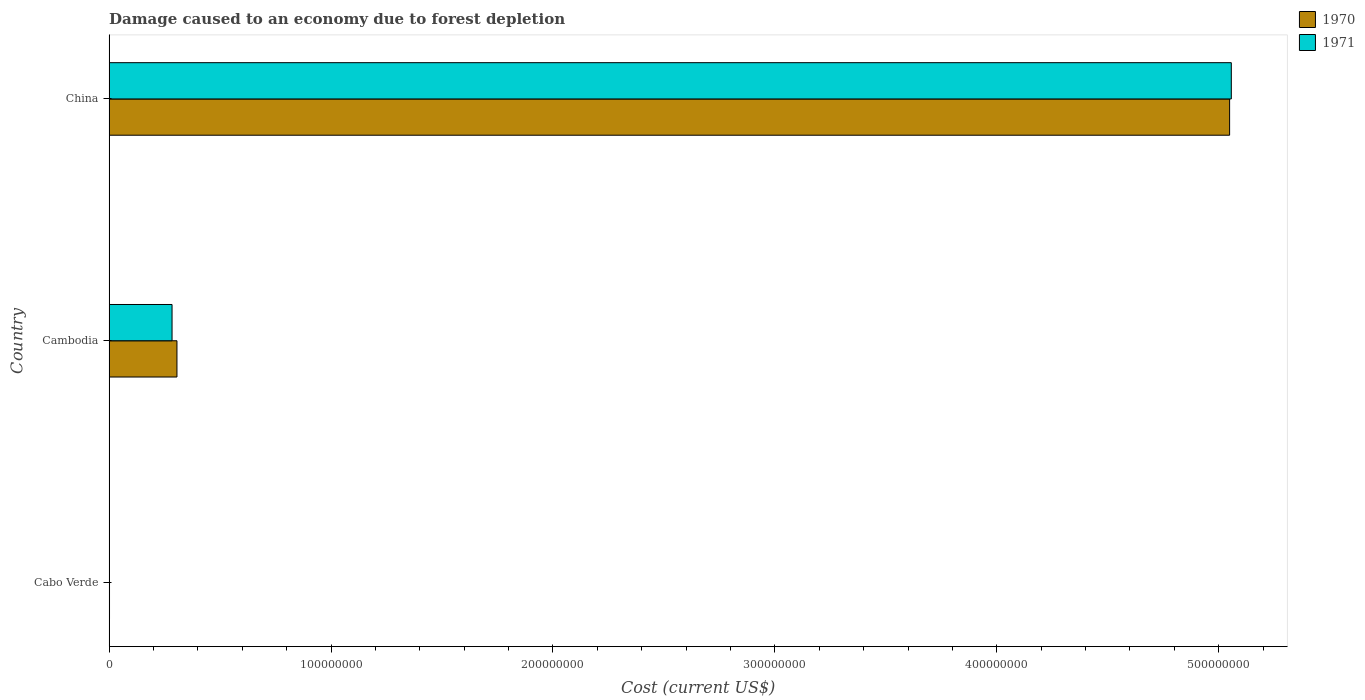Are the number of bars per tick equal to the number of legend labels?
Ensure brevity in your answer.  Yes. How many bars are there on the 2nd tick from the top?
Your answer should be compact. 2. What is the label of the 3rd group of bars from the top?
Ensure brevity in your answer.  Cabo Verde. In how many cases, is the number of bars for a given country not equal to the number of legend labels?
Make the answer very short. 0. What is the cost of damage caused due to forest depletion in 1970 in Cabo Verde?
Provide a succinct answer. 2.02e+05. Across all countries, what is the maximum cost of damage caused due to forest depletion in 1971?
Give a very brief answer. 5.06e+08. Across all countries, what is the minimum cost of damage caused due to forest depletion in 1971?
Make the answer very short. 1.81e+05. In which country was the cost of damage caused due to forest depletion in 1970 maximum?
Your answer should be compact. China. In which country was the cost of damage caused due to forest depletion in 1970 minimum?
Your answer should be compact. Cabo Verde. What is the total cost of damage caused due to forest depletion in 1970 in the graph?
Your answer should be very brief. 5.36e+08. What is the difference between the cost of damage caused due to forest depletion in 1970 in Cabo Verde and that in Cambodia?
Ensure brevity in your answer.  -3.04e+07. What is the difference between the cost of damage caused due to forest depletion in 1971 in Cambodia and the cost of damage caused due to forest depletion in 1970 in China?
Ensure brevity in your answer.  -4.77e+08. What is the average cost of damage caused due to forest depletion in 1970 per country?
Your response must be concise. 1.79e+08. What is the difference between the cost of damage caused due to forest depletion in 1971 and cost of damage caused due to forest depletion in 1970 in Cabo Verde?
Your answer should be compact. -2.17e+04. In how many countries, is the cost of damage caused due to forest depletion in 1970 greater than 280000000 US$?
Ensure brevity in your answer.  1. What is the ratio of the cost of damage caused due to forest depletion in 1970 in Cambodia to that in China?
Make the answer very short. 0.06. Is the cost of damage caused due to forest depletion in 1971 in Cabo Verde less than that in China?
Give a very brief answer. Yes. What is the difference between the highest and the second highest cost of damage caused due to forest depletion in 1971?
Your response must be concise. 4.77e+08. What is the difference between the highest and the lowest cost of damage caused due to forest depletion in 1970?
Give a very brief answer. 5.05e+08. In how many countries, is the cost of damage caused due to forest depletion in 1970 greater than the average cost of damage caused due to forest depletion in 1970 taken over all countries?
Your answer should be very brief. 1. Is the sum of the cost of damage caused due to forest depletion in 1971 in Cabo Verde and China greater than the maximum cost of damage caused due to forest depletion in 1970 across all countries?
Your answer should be very brief. Yes. What does the 2nd bar from the top in China represents?
Offer a very short reply. 1970. What does the 1st bar from the bottom in Cabo Verde represents?
Provide a short and direct response. 1970. Are all the bars in the graph horizontal?
Ensure brevity in your answer.  Yes. What is the difference between two consecutive major ticks on the X-axis?
Ensure brevity in your answer.  1.00e+08. Are the values on the major ticks of X-axis written in scientific E-notation?
Your response must be concise. No. Does the graph contain grids?
Ensure brevity in your answer.  No. Where does the legend appear in the graph?
Give a very brief answer. Top right. How are the legend labels stacked?
Your response must be concise. Vertical. What is the title of the graph?
Offer a terse response. Damage caused to an economy due to forest depletion. Does "2006" appear as one of the legend labels in the graph?
Give a very brief answer. No. What is the label or title of the X-axis?
Offer a very short reply. Cost (current US$). What is the label or title of the Y-axis?
Provide a succinct answer. Country. What is the Cost (current US$) in 1970 in Cabo Verde?
Your answer should be very brief. 2.02e+05. What is the Cost (current US$) in 1971 in Cabo Verde?
Give a very brief answer. 1.81e+05. What is the Cost (current US$) in 1970 in Cambodia?
Your answer should be very brief. 3.06e+07. What is the Cost (current US$) in 1971 in Cambodia?
Your response must be concise. 2.84e+07. What is the Cost (current US$) of 1970 in China?
Give a very brief answer. 5.05e+08. What is the Cost (current US$) in 1971 in China?
Keep it short and to the point. 5.06e+08. Across all countries, what is the maximum Cost (current US$) of 1970?
Your answer should be very brief. 5.05e+08. Across all countries, what is the maximum Cost (current US$) of 1971?
Keep it short and to the point. 5.06e+08. Across all countries, what is the minimum Cost (current US$) of 1970?
Provide a succinct answer. 2.02e+05. Across all countries, what is the minimum Cost (current US$) of 1971?
Your answer should be very brief. 1.81e+05. What is the total Cost (current US$) of 1970 in the graph?
Your response must be concise. 5.36e+08. What is the total Cost (current US$) in 1971 in the graph?
Make the answer very short. 5.34e+08. What is the difference between the Cost (current US$) in 1970 in Cabo Verde and that in Cambodia?
Give a very brief answer. -3.04e+07. What is the difference between the Cost (current US$) of 1971 in Cabo Verde and that in Cambodia?
Provide a succinct answer. -2.82e+07. What is the difference between the Cost (current US$) of 1970 in Cabo Verde and that in China?
Your response must be concise. -5.05e+08. What is the difference between the Cost (current US$) in 1971 in Cabo Verde and that in China?
Provide a succinct answer. -5.05e+08. What is the difference between the Cost (current US$) in 1970 in Cambodia and that in China?
Your answer should be compact. -4.74e+08. What is the difference between the Cost (current US$) in 1971 in Cambodia and that in China?
Provide a succinct answer. -4.77e+08. What is the difference between the Cost (current US$) in 1970 in Cabo Verde and the Cost (current US$) in 1971 in Cambodia?
Your answer should be compact. -2.82e+07. What is the difference between the Cost (current US$) in 1970 in Cabo Verde and the Cost (current US$) in 1971 in China?
Ensure brevity in your answer.  -5.05e+08. What is the difference between the Cost (current US$) in 1970 in Cambodia and the Cost (current US$) in 1971 in China?
Offer a very short reply. -4.75e+08. What is the average Cost (current US$) in 1970 per country?
Your response must be concise. 1.79e+08. What is the average Cost (current US$) in 1971 per country?
Give a very brief answer. 1.78e+08. What is the difference between the Cost (current US$) in 1970 and Cost (current US$) in 1971 in Cabo Verde?
Your response must be concise. 2.17e+04. What is the difference between the Cost (current US$) of 1970 and Cost (current US$) of 1971 in Cambodia?
Your response must be concise. 2.21e+06. What is the difference between the Cost (current US$) in 1970 and Cost (current US$) in 1971 in China?
Offer a very short reply. -7.69e+05. What is the ratio of the Cost (current US$) of 1970 in Cabo Verde to that in Cambodia?
Provide a short and direct response. 0.01. What is the ratio of the Cost (current US$) in 1971 in Cabo Verde to that in Cambodia?
Your answer should be compact. 0.01. What is the ratio of the Cost (current US$) of 1971 in Cabo Verde to that in China?
Offer a terse response. 0. What is the ratio of the Cost (current US$) in 1970 in Cambodia to that in China?
Offer a terse response. 0.06. What is the ratio of the Cost (current US$) in 1971 in Cambodia to that in China?
Offer a terse response. 0.06. What is the difference between the highest and the second highest Cost (current US$) of 1970?
Give a very brief answer. 4.74e+08. What is the difference between the highest and the second highest Cost (current US$) of 1971?
Provide a short and direct response. 4.77e+08. What is the difference between the highest and the lowest Cost (current US$) of 1970?
Offer a very short reply. 5.05e+08. What is the difference between the highest and the lowest Cost (current US$) in 1971?
Offer a very short reply. 5.05e+08. 